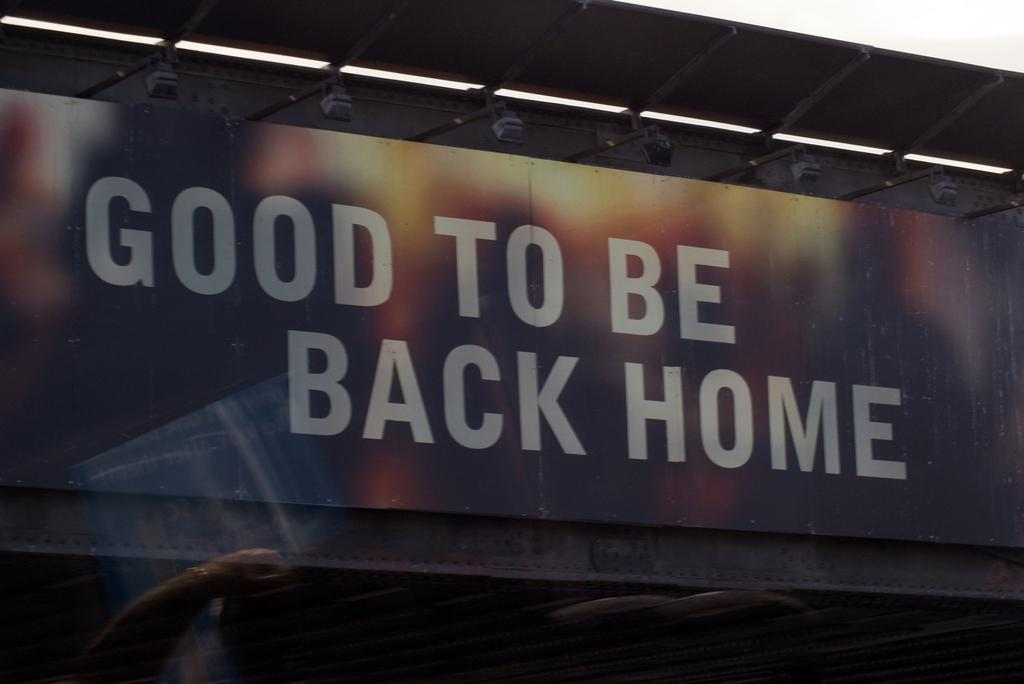<image>
Present a compact description of the photo's key features. a billboard with the slogan Good to be Back Home on it 